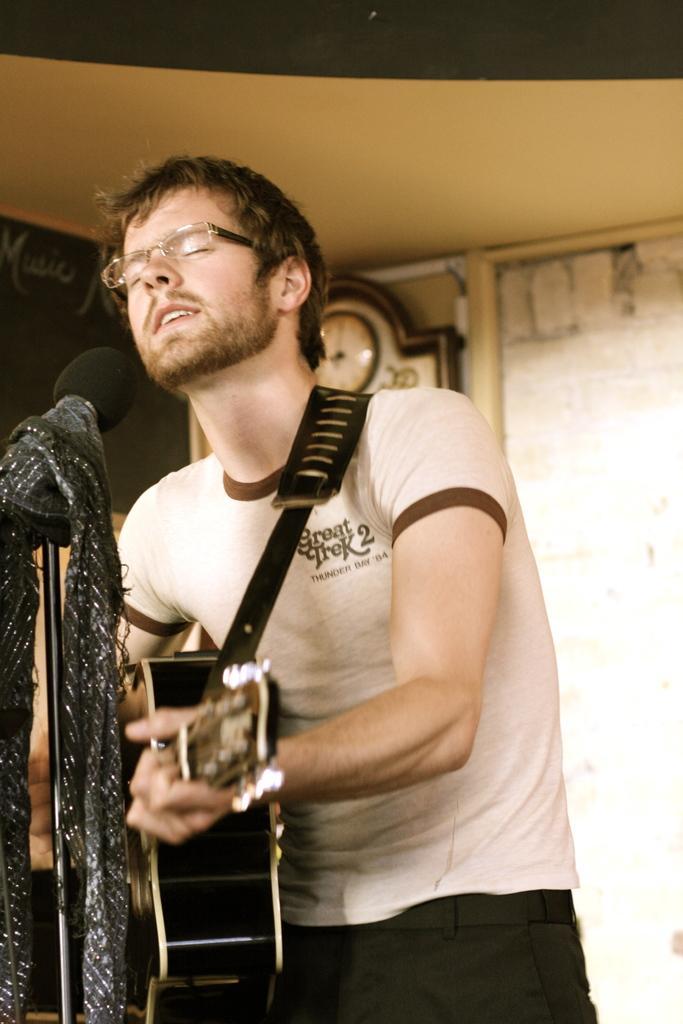Describe this image in one or two sentences. In this picture we can see a person,he is playing a guitar,here we can see a mic and in the background we can see a clock,wall. 